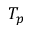Convert formula to latex. <formula><loc_0><loc_0><loc_500><loc_500>T _ { p }</formula> 